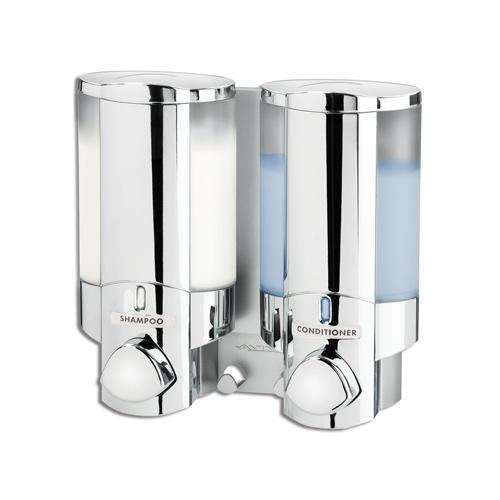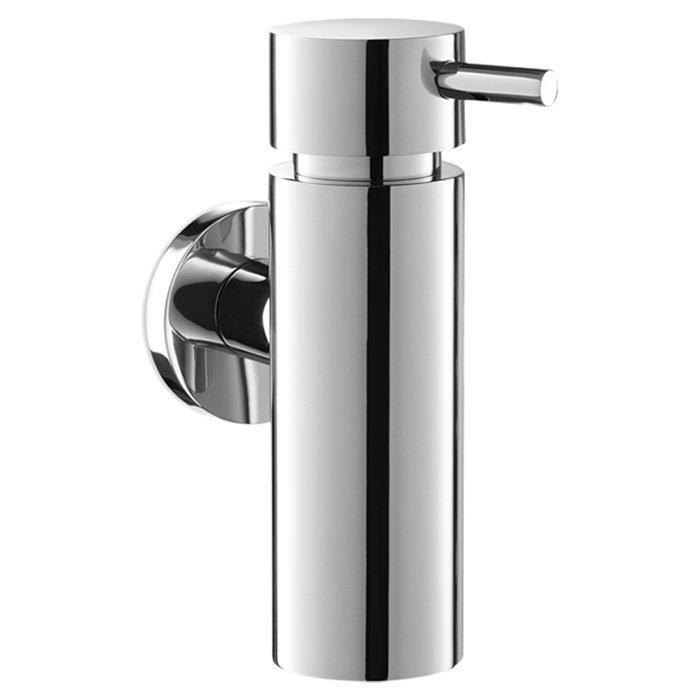The first image is the image on the left, the second image is the image on the right. Analyze the images presented: Is the assertion "One image features an opaque dispenser style with a top nozzle, and the other features a style that dispenses from the bottom and has a clear body." valid? Answer yes or no. Yes. The first image is the image on the left, the second image is the image on the right. Assess this claim about the two images: "At least one soap dispenser has a pump on top.". Correct or not? Answer yes or no. Yes. 